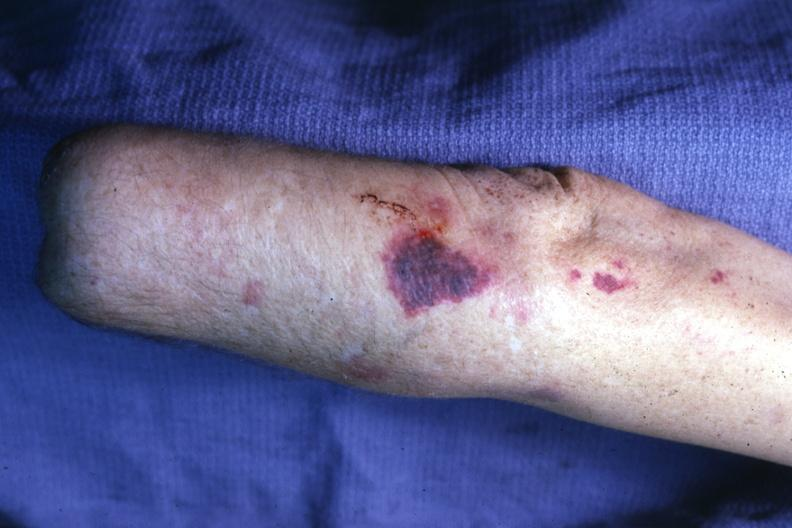s ecchymosis present?
Answer the question using a single word or phrase. Yes 